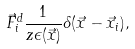<formula> <loc_0><loc_0><loc_500><loc_500>\vec { F } ^ { d } _ { i } \frac { 1 } { z \epsilon ( \vec { x } ) } \delta ( \vec { x } - \vec { x } _ { i } ) ,</formula> 